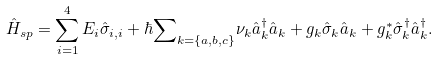<formula> <loc_0><loc_0><loc_500><loc_500>\hat { H } _ { s p } = \sum ^ { 4 } _ { i = 1 } E _ { i } \hat { \sigma } _ { i , i } + \hbar { \sum } _ { k = \{ a , b , c \} } \nu _ { k } \hat { a } ^ { \dag } _ { k } \hat { a } _ { k } + g _ { k } \hat { \sigma } _ { k } \hat { a } _ { k } + g ^ { * } _ { k } \hat { \sigma } ^ { \dag } _ { k } \hat { a } ^ { \dag } _ { k } .</formula> 